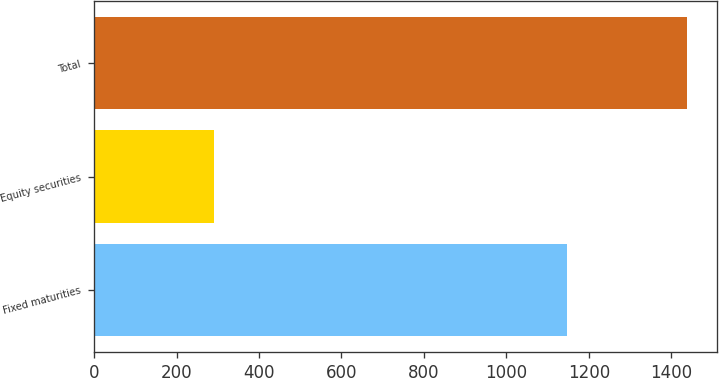Convert chart to OTSL. <chart><loc_0><loc_0><loc_500><loc_500><bar_chart><fcel>Fixed maturities<fcel>Equity securities<fcel>Total<nl><fcel>1148<fcel>291<fcel>1439<nl></chart> 